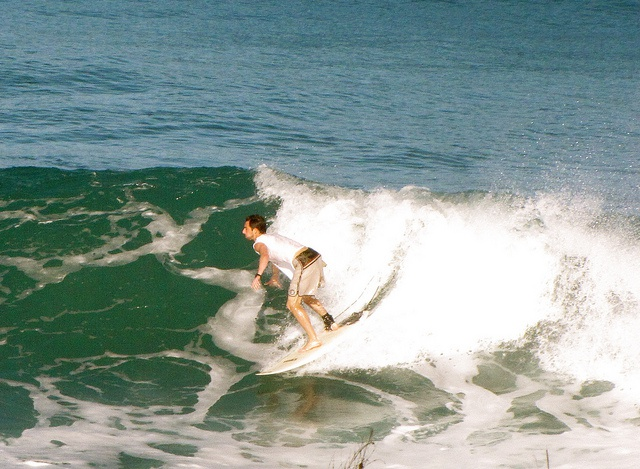Describe the objects in this image and their specific colors. I can see people in teal, white, and tan tones and surfboard in teal, white, and tan tones in this image. 